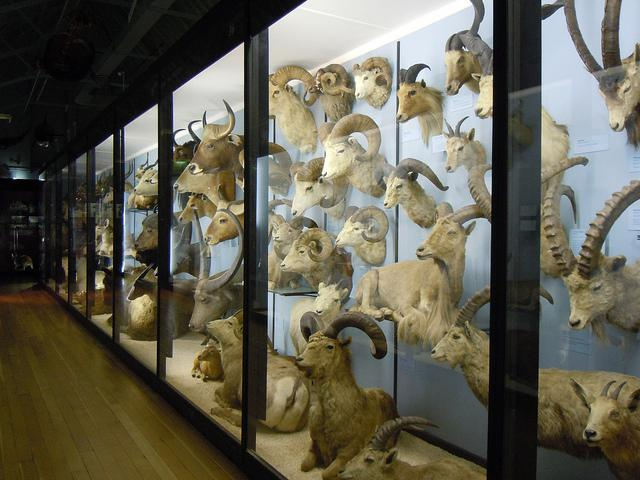What form of art was used to preserve these dead animals? taxidermy 